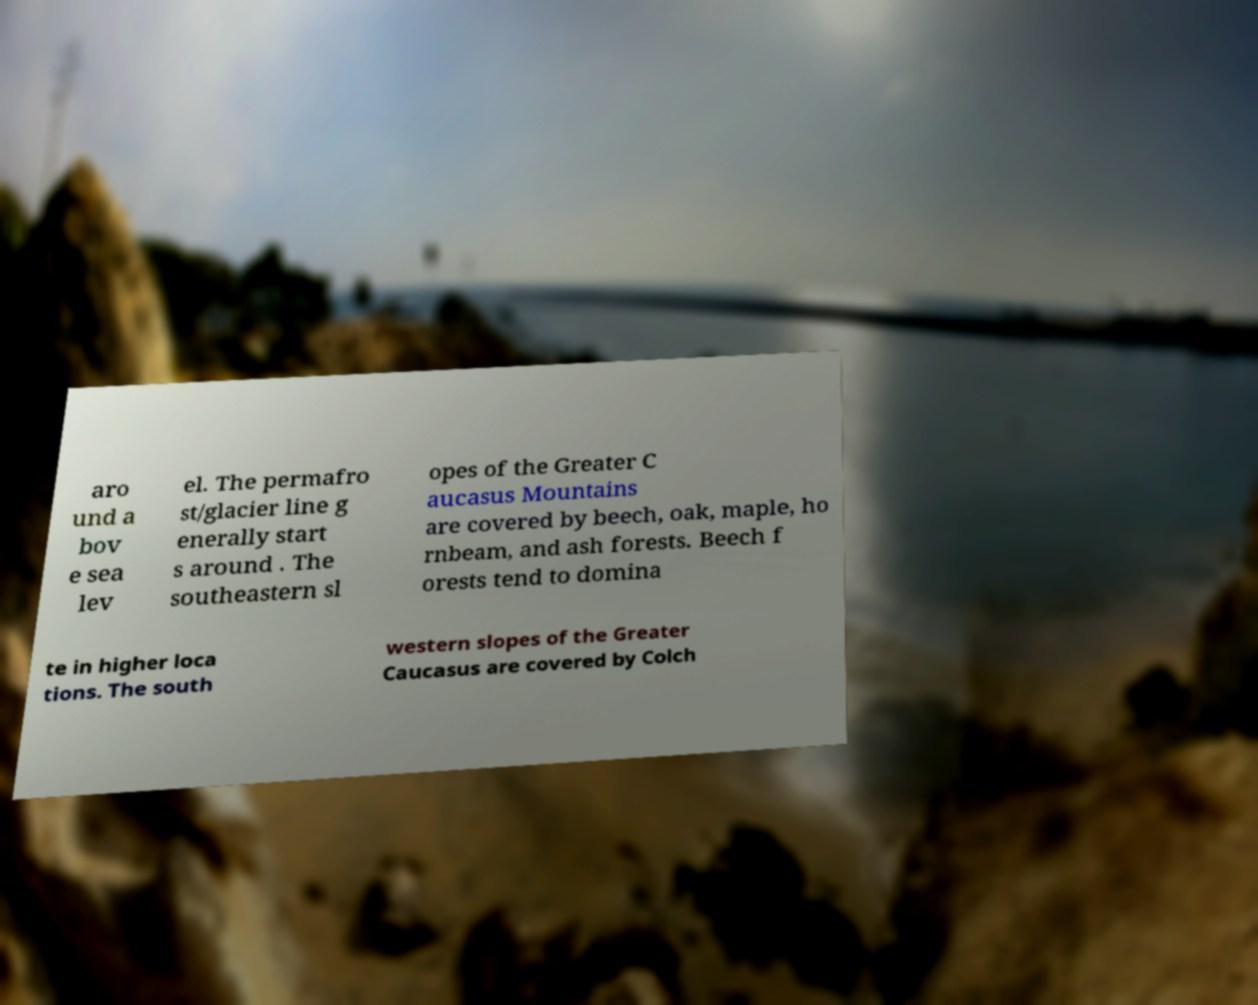What messages or text are displayed in this image? I need them in a readable, typed format. aro und a bov e sea lev el. The permafro st/glacier line g enerally start s around . The southeastern sl opes of the Greater C aucasus Mountains are covered by beech, oak, maple, ho rnbeam, and ash forests. Beech f orests tend to domina te in higher loca tions. The south western slopes of the Greater Caucasus are covered by Colch 